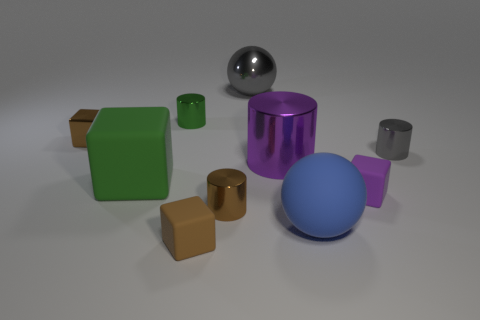Subtract all tiny green cylinders. How many cylinders are left? 3 Subtract all green balls. How many brown blocks are left? 2 Subtract all green blocks. How many blocks are left? 3 Subtract all spheres. How many objects are left? 8 Subtract 1 cylinders. How many cylinders are left? 3 Subtract all small green metallic blocks. Subtract all tiny green cylinders. How many objects are left? 9 Add 1 metal cubes. How many metal cubes are left? 2 Add 4 blue rubber balls. How many blue rubber balls exist? 5 Subtract 0 cyan spheres. How many objects are left? 10 Subtract all purple cubes. Subtract all brown cylinders. How many cubes are left? 3 